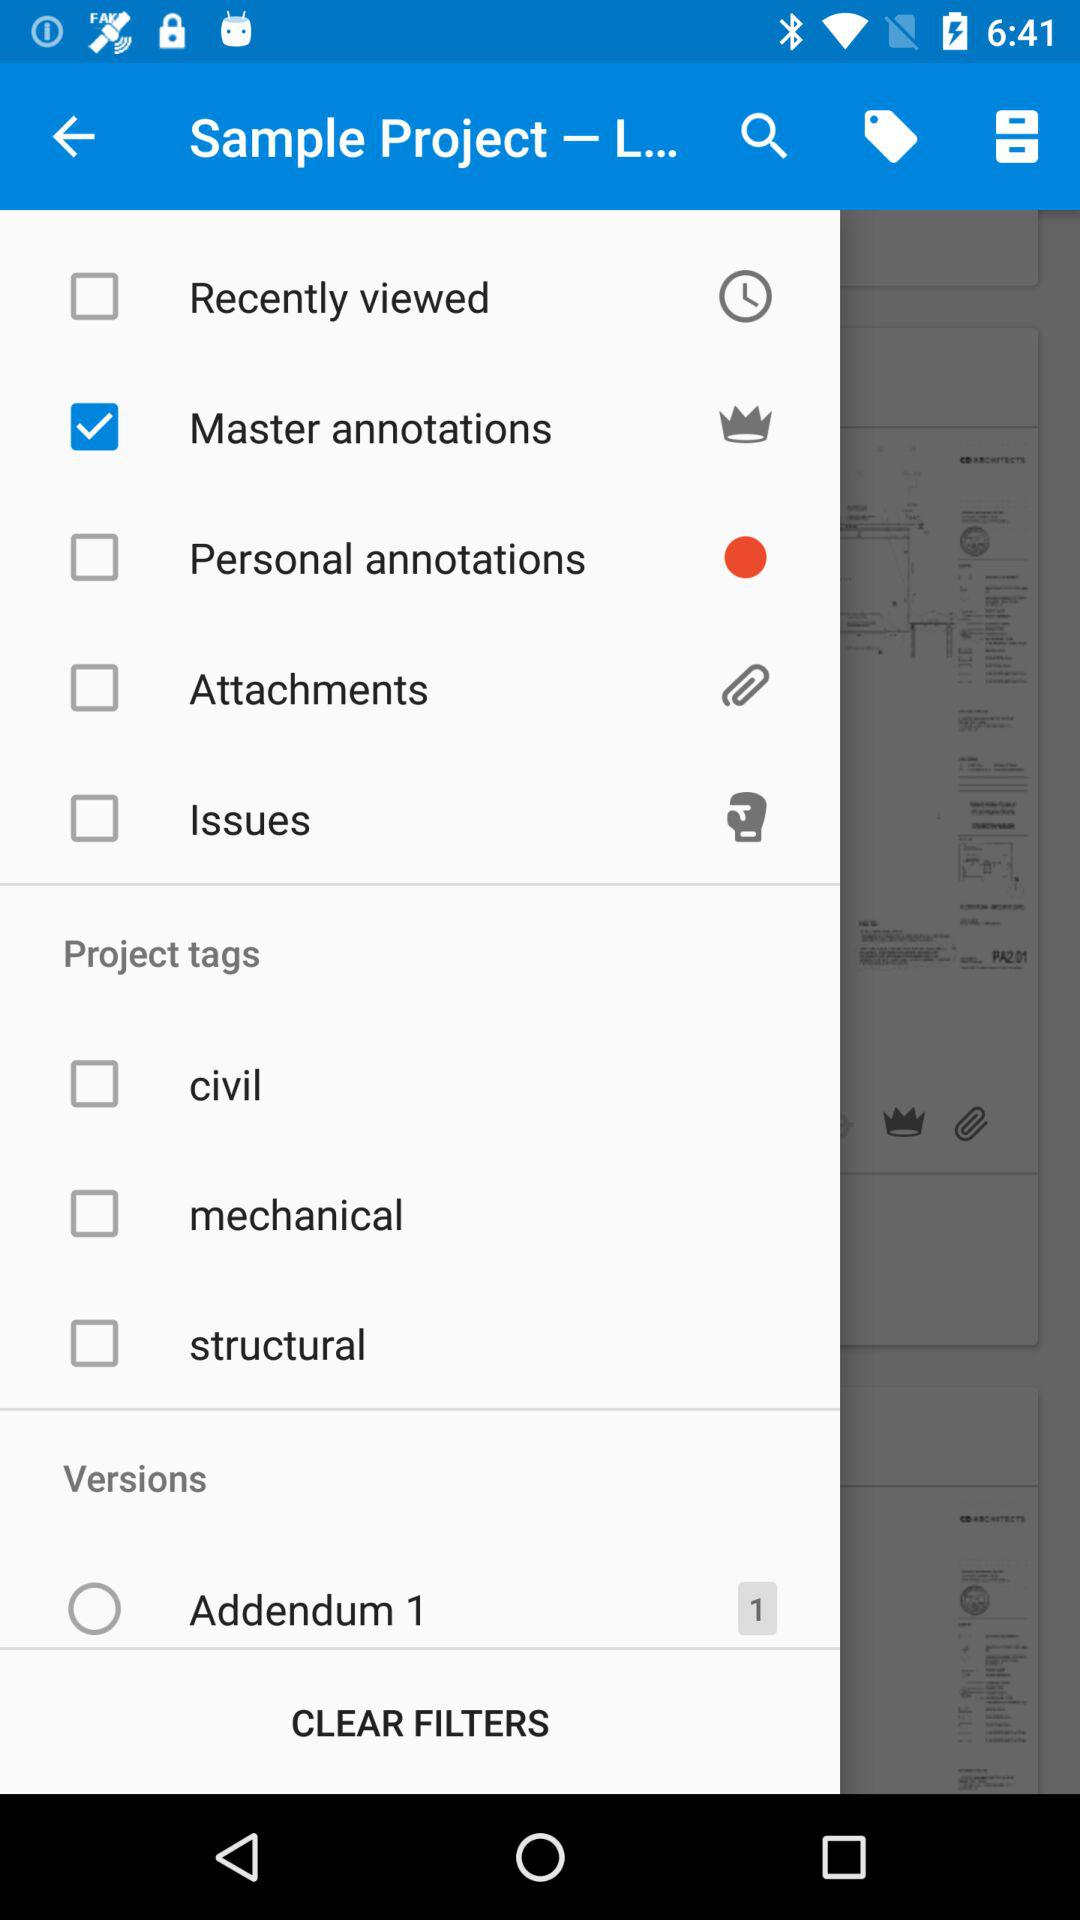How many notifications for "Addendum 1" are there? There is 1 notification for "Addendum 1". 